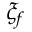Convert formula to latex. <formula><loc_0><loc_0><loc_500><loc_500>\xi _ { f }</formula> 